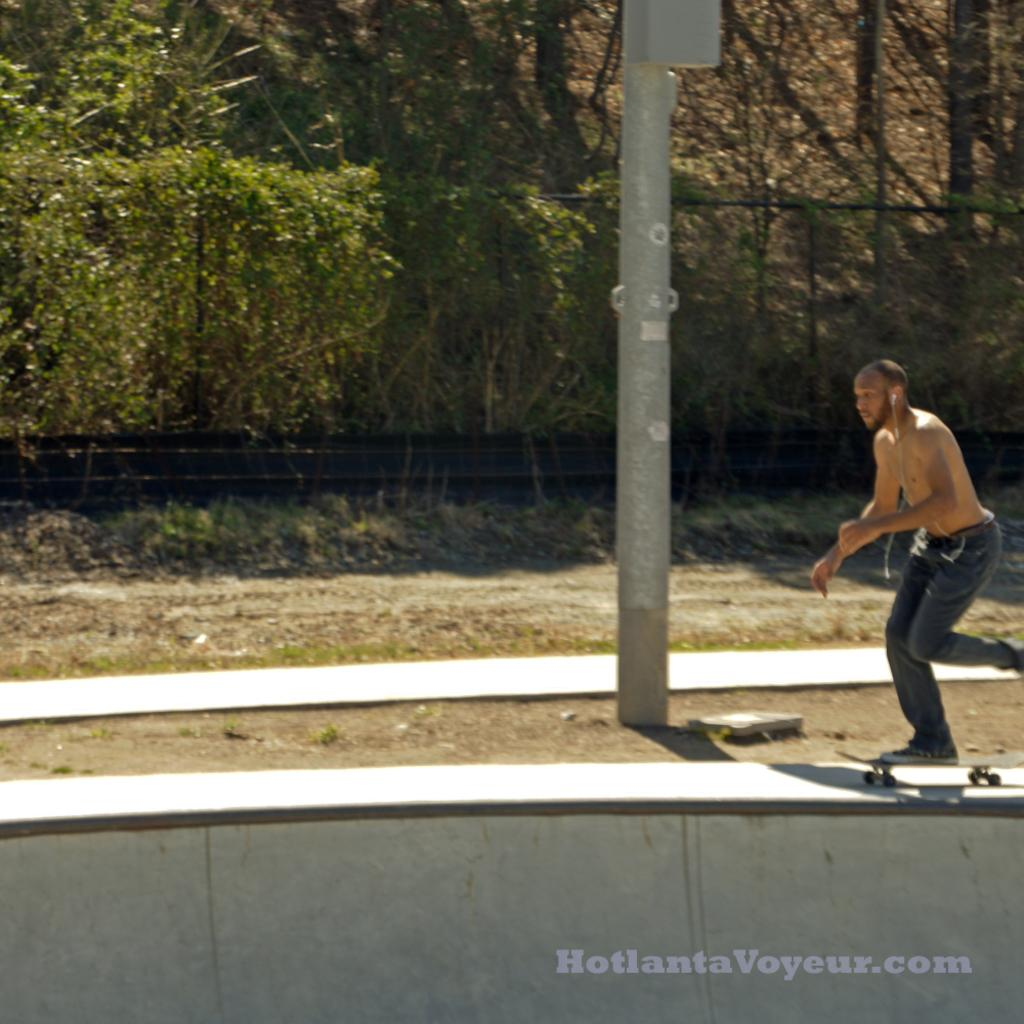What activity is the person in the image engaged in? There is a person skating in the image. What object can be seen in the image besides the person? There is a pole in the image. What can be seen in the background of the image? There is a fence and trees in the background of the image. How many friends does the person skating have in the image? There is no information about friends in the image, as it only shows a person skating and a pole. 